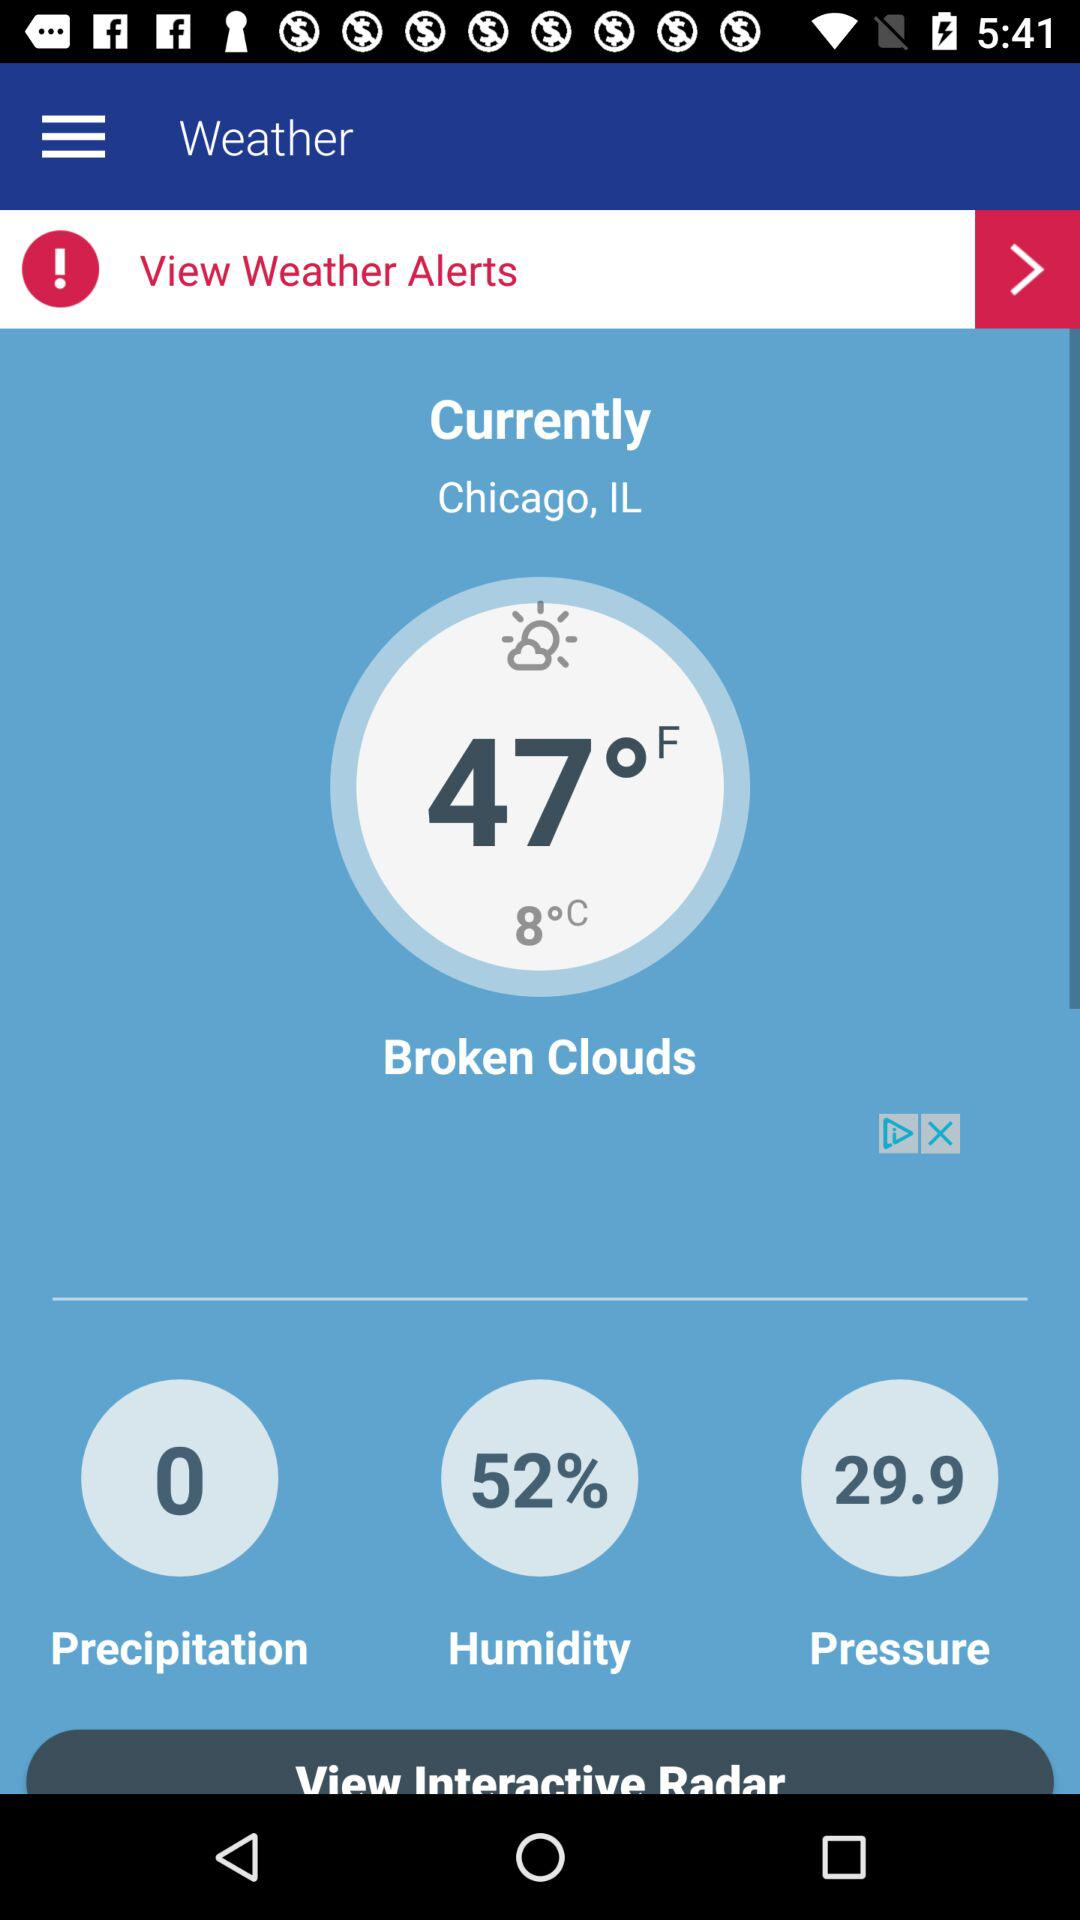What is the location? The location is Chicago, IL. 